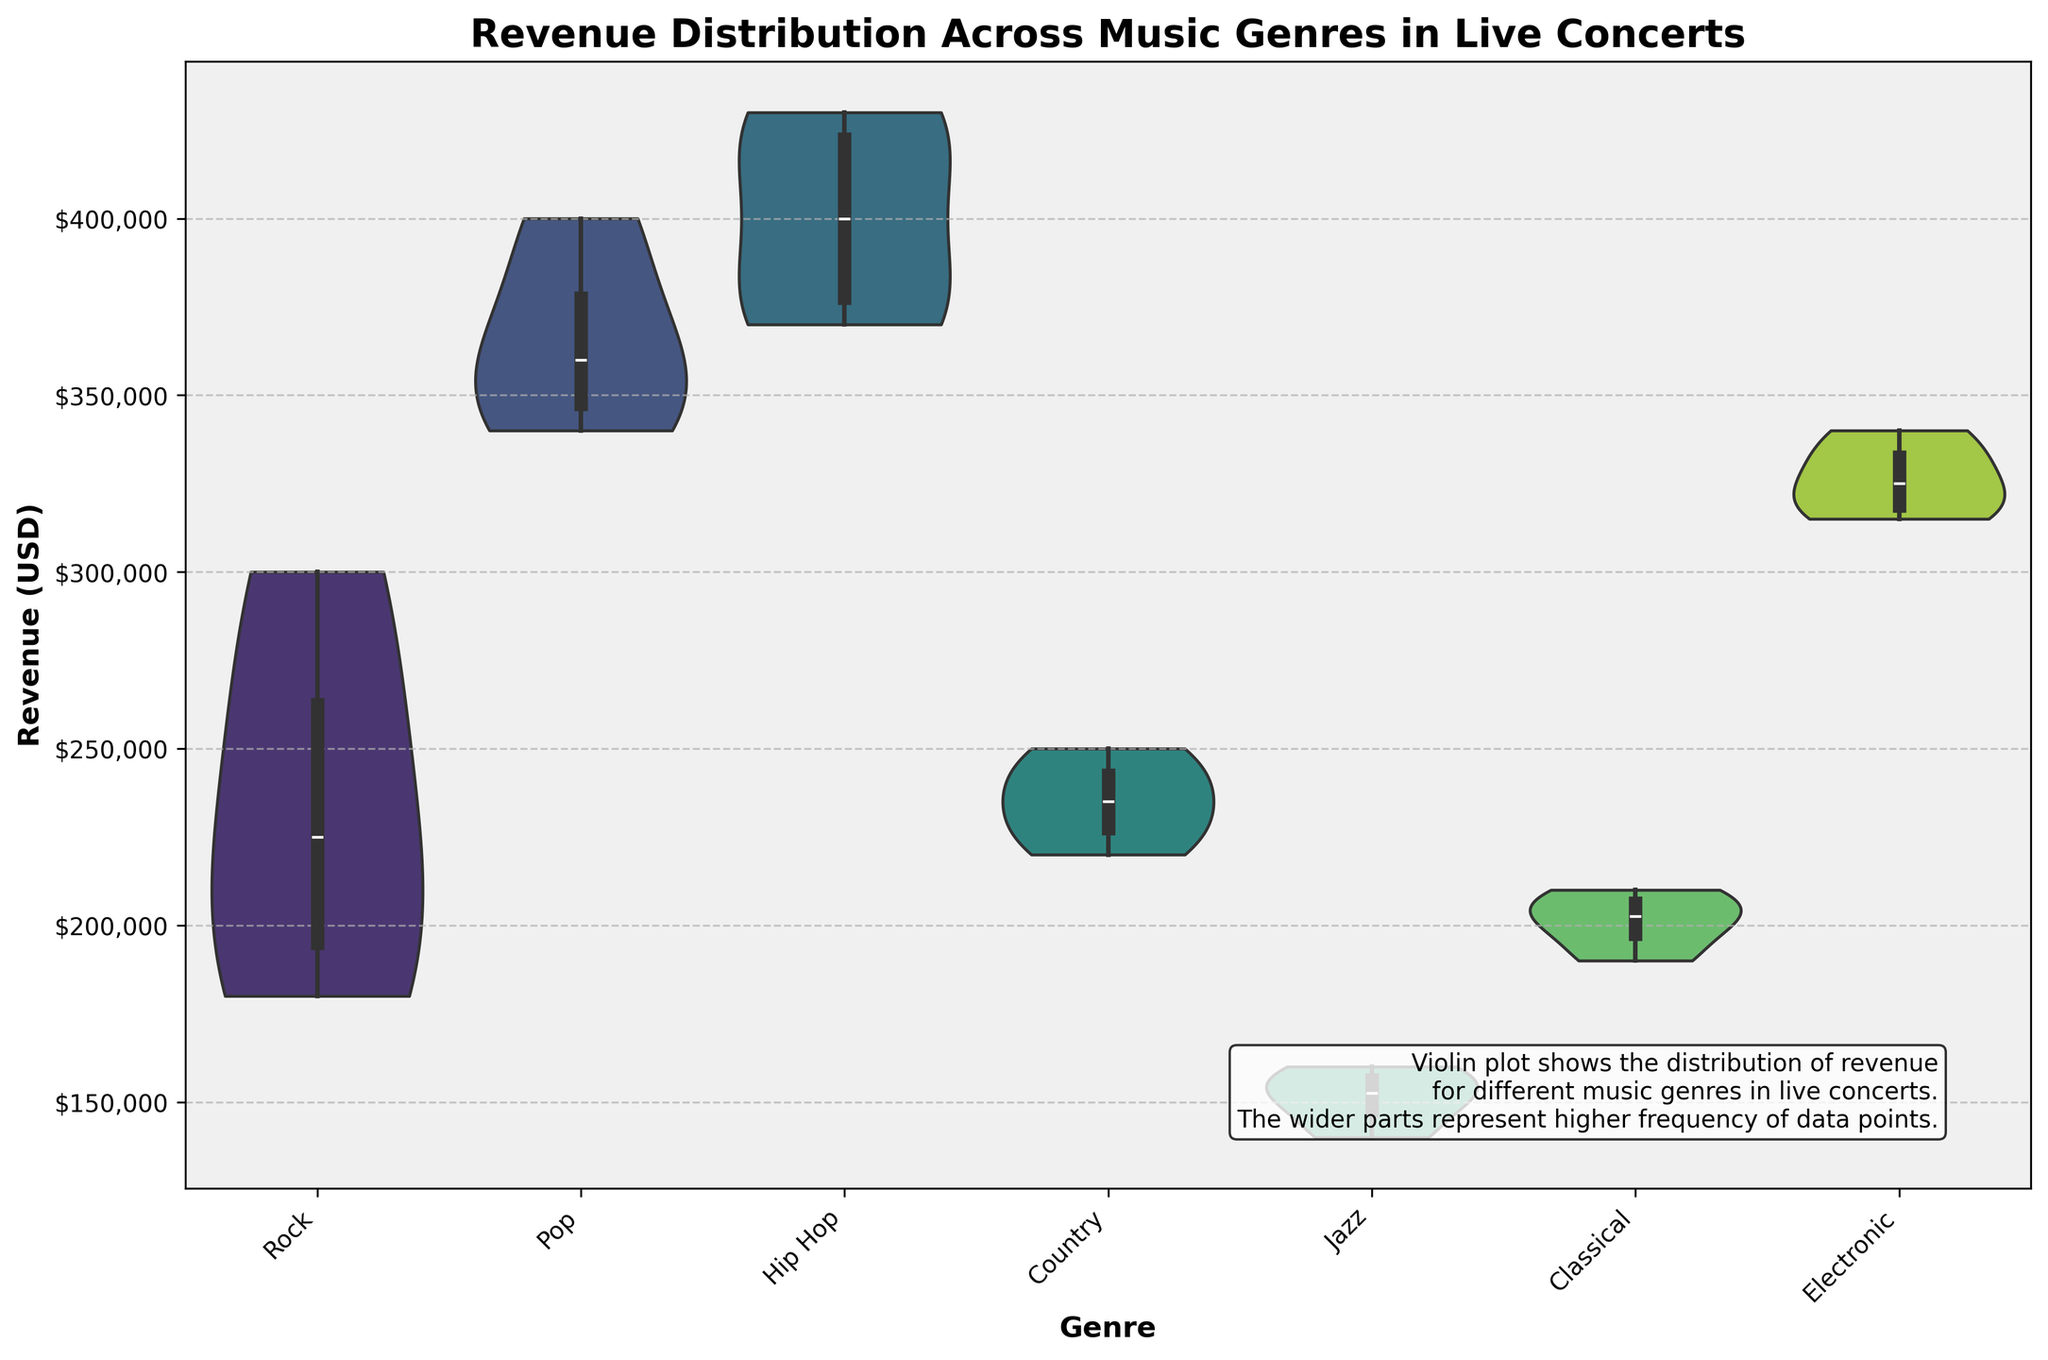Which genre has the highest median revenue in live concerts? Observing the width of the violin plots, which correspond to the frequency of the data points, and the position of the "inner" box plot (which represents the median), Hip Hop has the highest median revenue in live concerts.
Answer: Hip Hop What is the range of the revenue for the Pop genre? To find the range, look at the highest and lowest points of the violin plot for the Pop genre. The highest is around $400,000 and the lowest is around $340,000, so the range is $400,000 - $340,000.
Answer: $60,000 Which genre shows the most variability in concert revenue? Variability can be observed by the width and spread of the violin plots. The Rock genre shows the most variability, indicated by its more extensive spread compared to other genres.
Answer: Rock What is the average revenue of classical concerts depicted in the plot? Observing the box plot within the violin, the average revenue can be approximated. The Classical genre shows an average close to $200,000. To be more exact, we'd sum the revenues ($200,000 + $190,000 + $210,000 + $205,000) and average them: (200,000 + 190,000 + 210,000 + 205,000) / 4.
Answer: $201,250 How does the revenue distribution of the Jazz genre compare to the Electronic genre? By comparing the positions and widths of their respective violin plots, Jazz has a lower and more narrow revenue distribution, mainly ranging between $140,000 and $160,000, while Electronic's distribution is higher, between $315,000 and $340,000.
Answer: Jazz: lower, narrower; Electronic: higher, more varied Which music genre has the widest range of revenues in the dataset? The range is seen by the vertical spread within the violin plot. Rock shows the widest range, from $180,000 to $300,000.
Answer: Rock Are revenues from Hip Hop concerts generally higher than revenues from Electronic concerts? By comparing the median and overall distribution, Hip Hop concerts have a higher median revenue and generally higher revenue distribution compared to Electronic concerts.
Answer: Yes What is the revenue distribution shape for the Country genre? The violin plot for Country is pretty symmetric and shows a middle spread between $220,000 and $250,000 without significant outliers, suggesting a normal distribution.
Answer: Symmetric, normal distribution Which genre has the most concentrated revenue around the median? By looking for the violin plot with narrower sections around the median, Pop appears to have its revenues more concentrated around its median compared to other genres.
Answer: Pop 